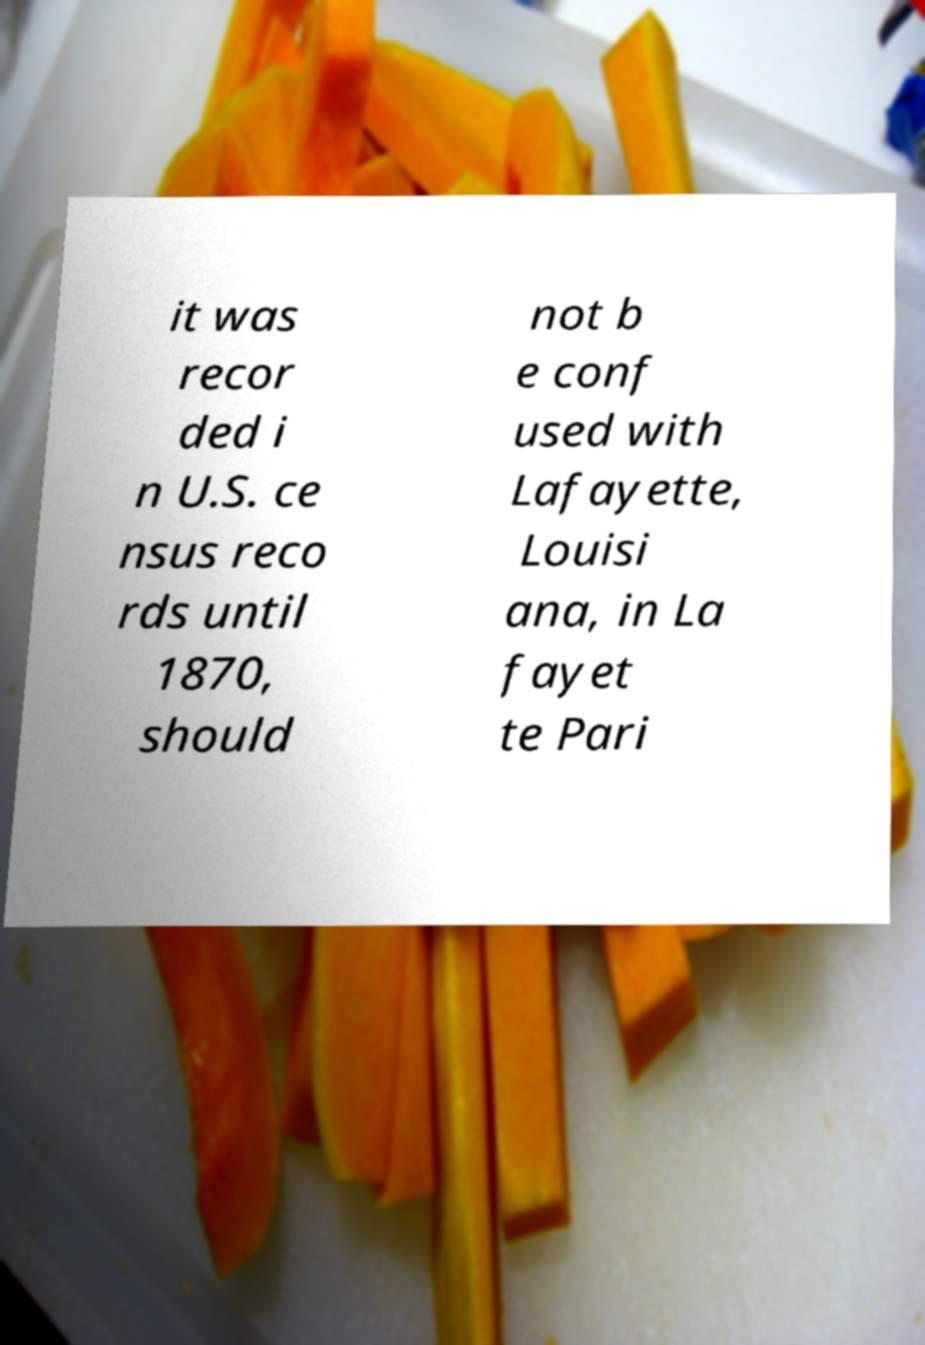I need the written content from this picture converted into text. Can you do that? it was recor ded i n U.S. ce nsus reco rds until 1870, should not b e conf used with Lafayette, Louisi ana, in La fayet te Pari 